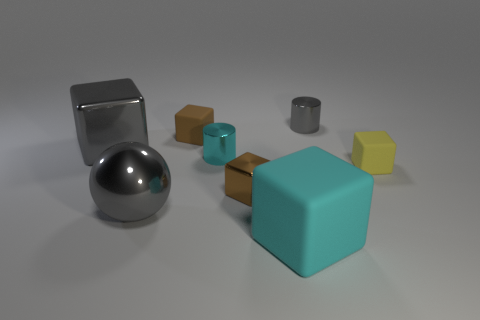Subtract all gray cubes. How many cubes are left? 4 Subtract all yellow blocks. How many blocks are left? 4 Add 3 brown metallic things. How many brown metallic things are left? 4 Add 7 gray spheres. How many gray spheres exist? 8 Add 2 big yellow matte cylinders. How many objects exist? 10 Subtract 0 brown cylinders. How many objects are left? 8 Subtract all cylinders. How many objects are left? 6 Subtract 4 blocks. How many blocks are left? 1 Subtract all yellow cylinders. Subtract all purple spheres. How many cylinders are left? 2 Subtract all cyan cylinders. How many brown cubes are left? 2 